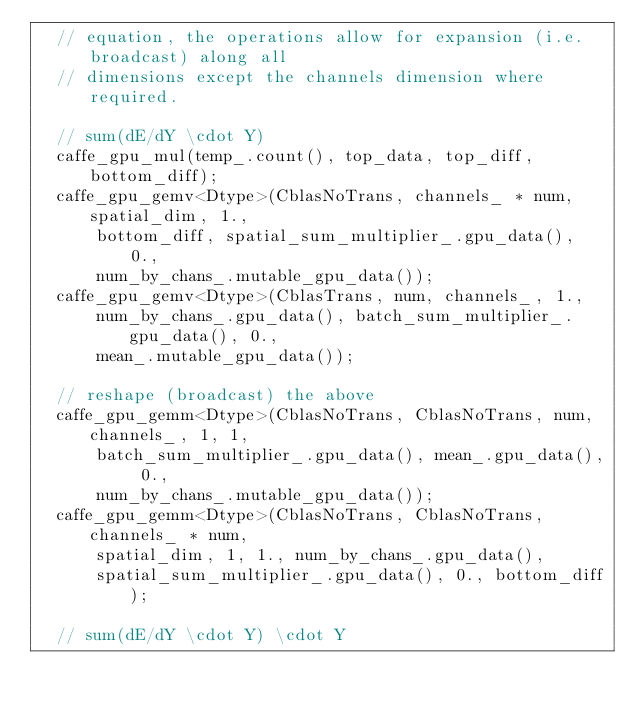Convert code to text. <code><loc_0><loc_0><loc_500><loc_500><_Cuda_>  // equation, the operations allow for expansion (i.e. broadcast) along all
  // dimensions except the channels dimension where required.

  // sum(dE/dY \cdot Y)
  caffe_gpu_mul(temp_.count(), top_data, top_diff, bottom_diff);
  caffe_gpu_gemv<Dtype>(CblasNoTrans, channels_ * num, spatial_dim, 1.,
      bottom_diff, spatial_sum_multiplier_.gpu_data(), 0.,
      num_by_chans_.mutable_gpu_data());
  caffe_gpu_gemv<Dtype>(CblasTrans, num, channels_, 1.,
      num_by_chans_.gpu_data(), batch_sum_multiplier_.gpu_data(), 0.,
      mean_.mutable_gpu_data());

  // reshape (broadcast) the above
  caffe_gpu_gemm<Dtype>(CblasNoTrans, CblasNoTrans, num, channels_, 1, 1,
      batch_sum_multiplier_.gpu_data(), mean_.gpu_data(), 0.,
      num_by_chans_.mutable_gpu_data());
  caffe_gpu_gemm<Dtype>(CblasNoTrans, CblasNoTrans, channels_ * num,
      spatial_dim, 1, 1., num_by_chans_.gpu_data(),
      spatial_sum_multiplier_.gpu_data(), 0., bottom_diff);

  // sum(dE/dY \cdot Y) \cdot Y</code> 